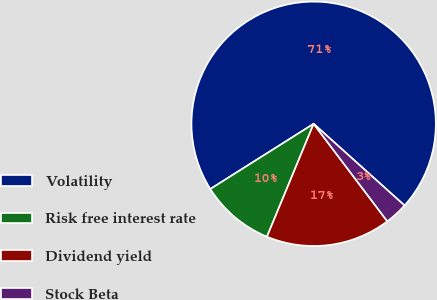<chart> <loc_0><loc_0><loc_500><loc_500><pie_chart><fcel>Volatility<fcel>Risk free interest rate<fcel>Dividend yield<fcel>Stock Beta<nl><fcel>70.61%<fcel>9.8%<fcel>16.54%<fcel>3.05%<nl></chart> 